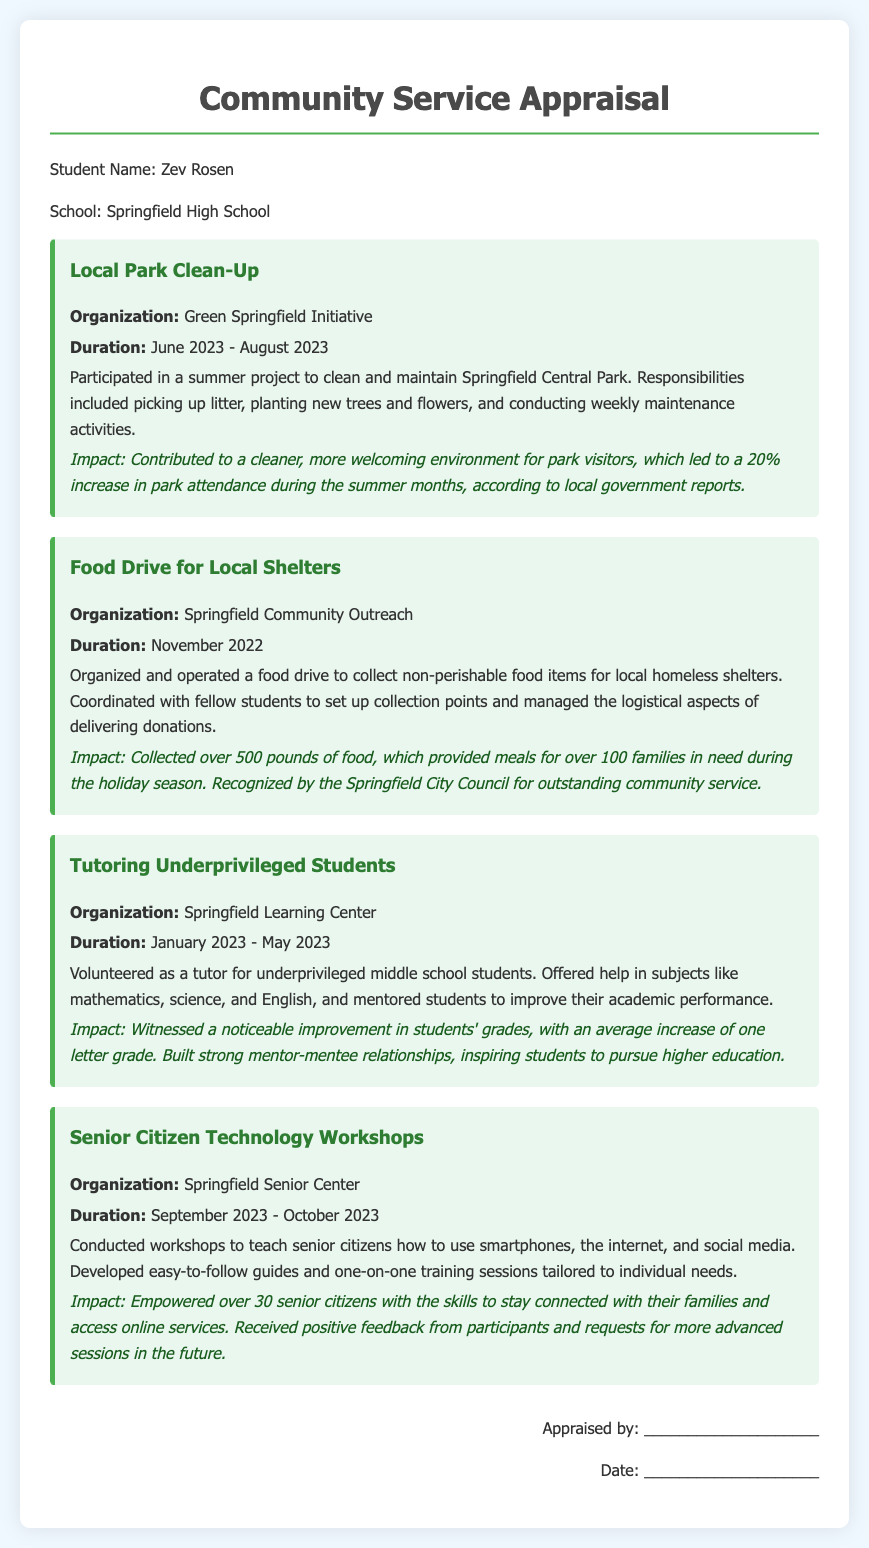What is the name of the student? The document begins by clearly stating the student's name at the top, which is Zev Rosen.
Answer: Zev Rosen What is the organization for the summer park project? In the project description for the Local Park Clean-Up, the organization involved is mentioned as the Green Springfield Initiative.
Answer: Green Springfield Initiative How many pounds of food were collected during the food drive? The Food Drive project section specifies that over 500 pounds of food were collected for local homeless shelters.
Answer: 500 pounds During which months did Zev participate in the tutoring project? The Tutoring Underprivileged Students project states the duration was from January 2023 to May 2023.
Answer: January 2023 - May 2023 What specific skills were taught in the Senior Citizen Technology Workshops? The Senior Citizen Technology Workshops detailed that workshops focused on smartphones, the internet, and social media.
Answer: Smartphones, internet, social media How did the park clean-up impact park attendance? The impact statement for the Local Park Clean-Up project indicates that there was a 20% increase in park attendance during the summer months.
Answer: 20% increase Which organization recognized the food drive for outstanding community service? The impact section regarding the Food Drive notes that recognition came from the Springfield City Council for outstanding community service.
Answer: Springfield City Council What improvement was seen in students' grades during the tutoring? The impact statement highlights that there was an average increase of one letter grade for the students tutored.
Answer: One letter grade How many senior citizens participated in the workshops? The Senior Citizen Technology Workshops indicated that over 30 senior citizens were empowered with new skills as a result of the program.
Answer: Over 30 senior citizens 